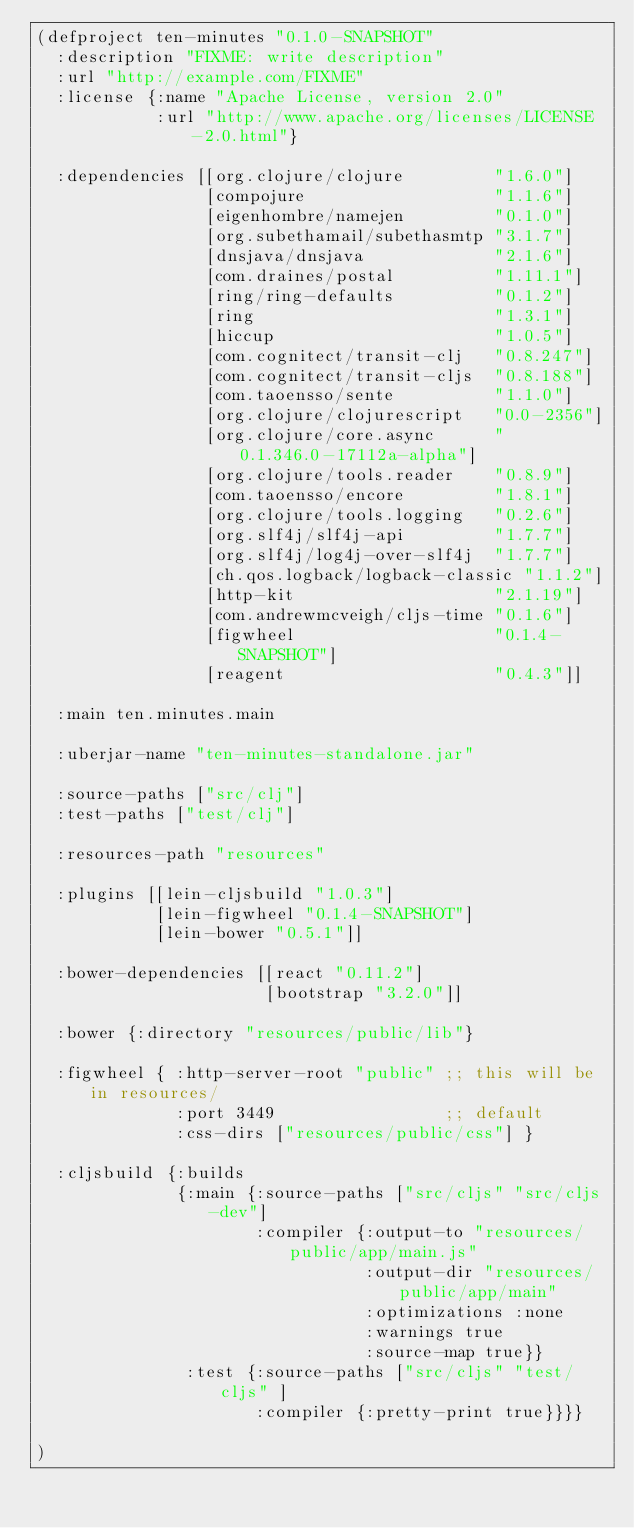<code> <loc_0><loc_0><loc_500><loc_500><_Clojure_>(defproject ten-minutes "0.1.0-SNAPSHOT"
  :description "FIXME: write description"
  :url "http://example.com/FIXME"
  :license {:name "Apache License, version 2.0"
            :url "http://www.apache.org/licenses/LICENSE-2.0.html"}

  :dependencies [[org.clojure/clojure         "1.6.0"]
                 [compojure                   "1.1.6"]
                 [eigenhombre/namejen         "0.1.0"]
                 [org.subethamail/subethasmtp "3.1.7"]
                 [dnsjava/dnsjava             "2.1.6"]
                 [com.draines/postal          "1.11.1"]
                 [ring/ring-defaults          "0.1.2"]
                 [ring                        "1.3.1"]
                 [hiccup                      "1.0.5"]
                 [com.cognitect/transit-clj   "0.8.247"]
                 [com.cognitect/transit-cljs  "0.8.188"]
                 [com.taoensso/sente          "1.1.0"]
                 [org.clojure/clojurescript   "0.0-2356"]
                 [org.clojure/core.async      "0.1.346.0-17112a-alpha"]
                 [org.clojure/tools.reader    "0.8.9"]
                 [com.taoensso/encore         "1.8.1"]
                 [org.clojure/tools.logging   "0.2.6"]
                 [org.slf4j/slf4j-api         "1.7.7"]
                 [org.slf4j/log4j-over-slf4j  "1.7.7"]
                 [ch.qos.logback/logback-classic "1.1.2"]
                 [http-kit                    "2.1.19"]
                 [com.andrewmcveigh/cljs-time "0.1.6"]
                 [figwheel                    "0.1.4-SNAPSHOT"]
                 [reagent                     "0.4.3"]]

  :main ten.minutes.main

  :uberjar-name "ten-minutes-standalone.jar"

  :source-paths ["src/clj"]
  :test-paths ["test/clj"]

  :resources-path "resources"

  :plugins [[lein-cljsbuild "1.0.3"]
            [lein-figwheel "0.1.4-SNAPSHOT"]
            [lein-bower "0.5.1"]]

  :bower-dependencies [[react "0.11.2"]
                       [bootstrap "3.2.0"]]

  :bower {:directory "resources/public/lib"}

  :figwheel { :http-server-root "public" ;; this will be in resources/
              :port 3449                 ;; default
              :css-dirs ["resources/public/css"] }

  :cljsbuild {:builds
              {:main {:source-paths ["src/cljs" "src/cljs-dev"]
                      :compiler {:output-to "resources/public/app/main.js"
                                 :output-dir "resources/public/app/main"
                                 :optimizations :none
                                 :warnings true
                                 :source-map true}}
               :test {:source-paths ["src/cljs" "test/cljs" ]
                      :compiler {:pretty-print true}}}}

)
</code> 